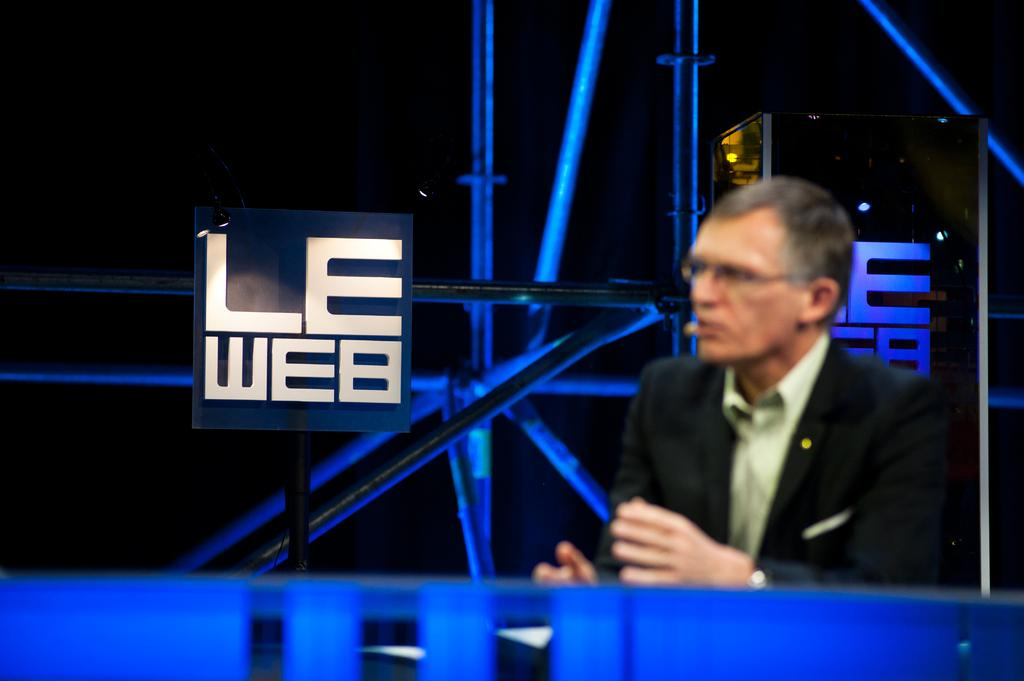<image>
Present a compact description of the photo's key features. A man wearing a microphone on his face positioned next to a sign that says Le Web. 